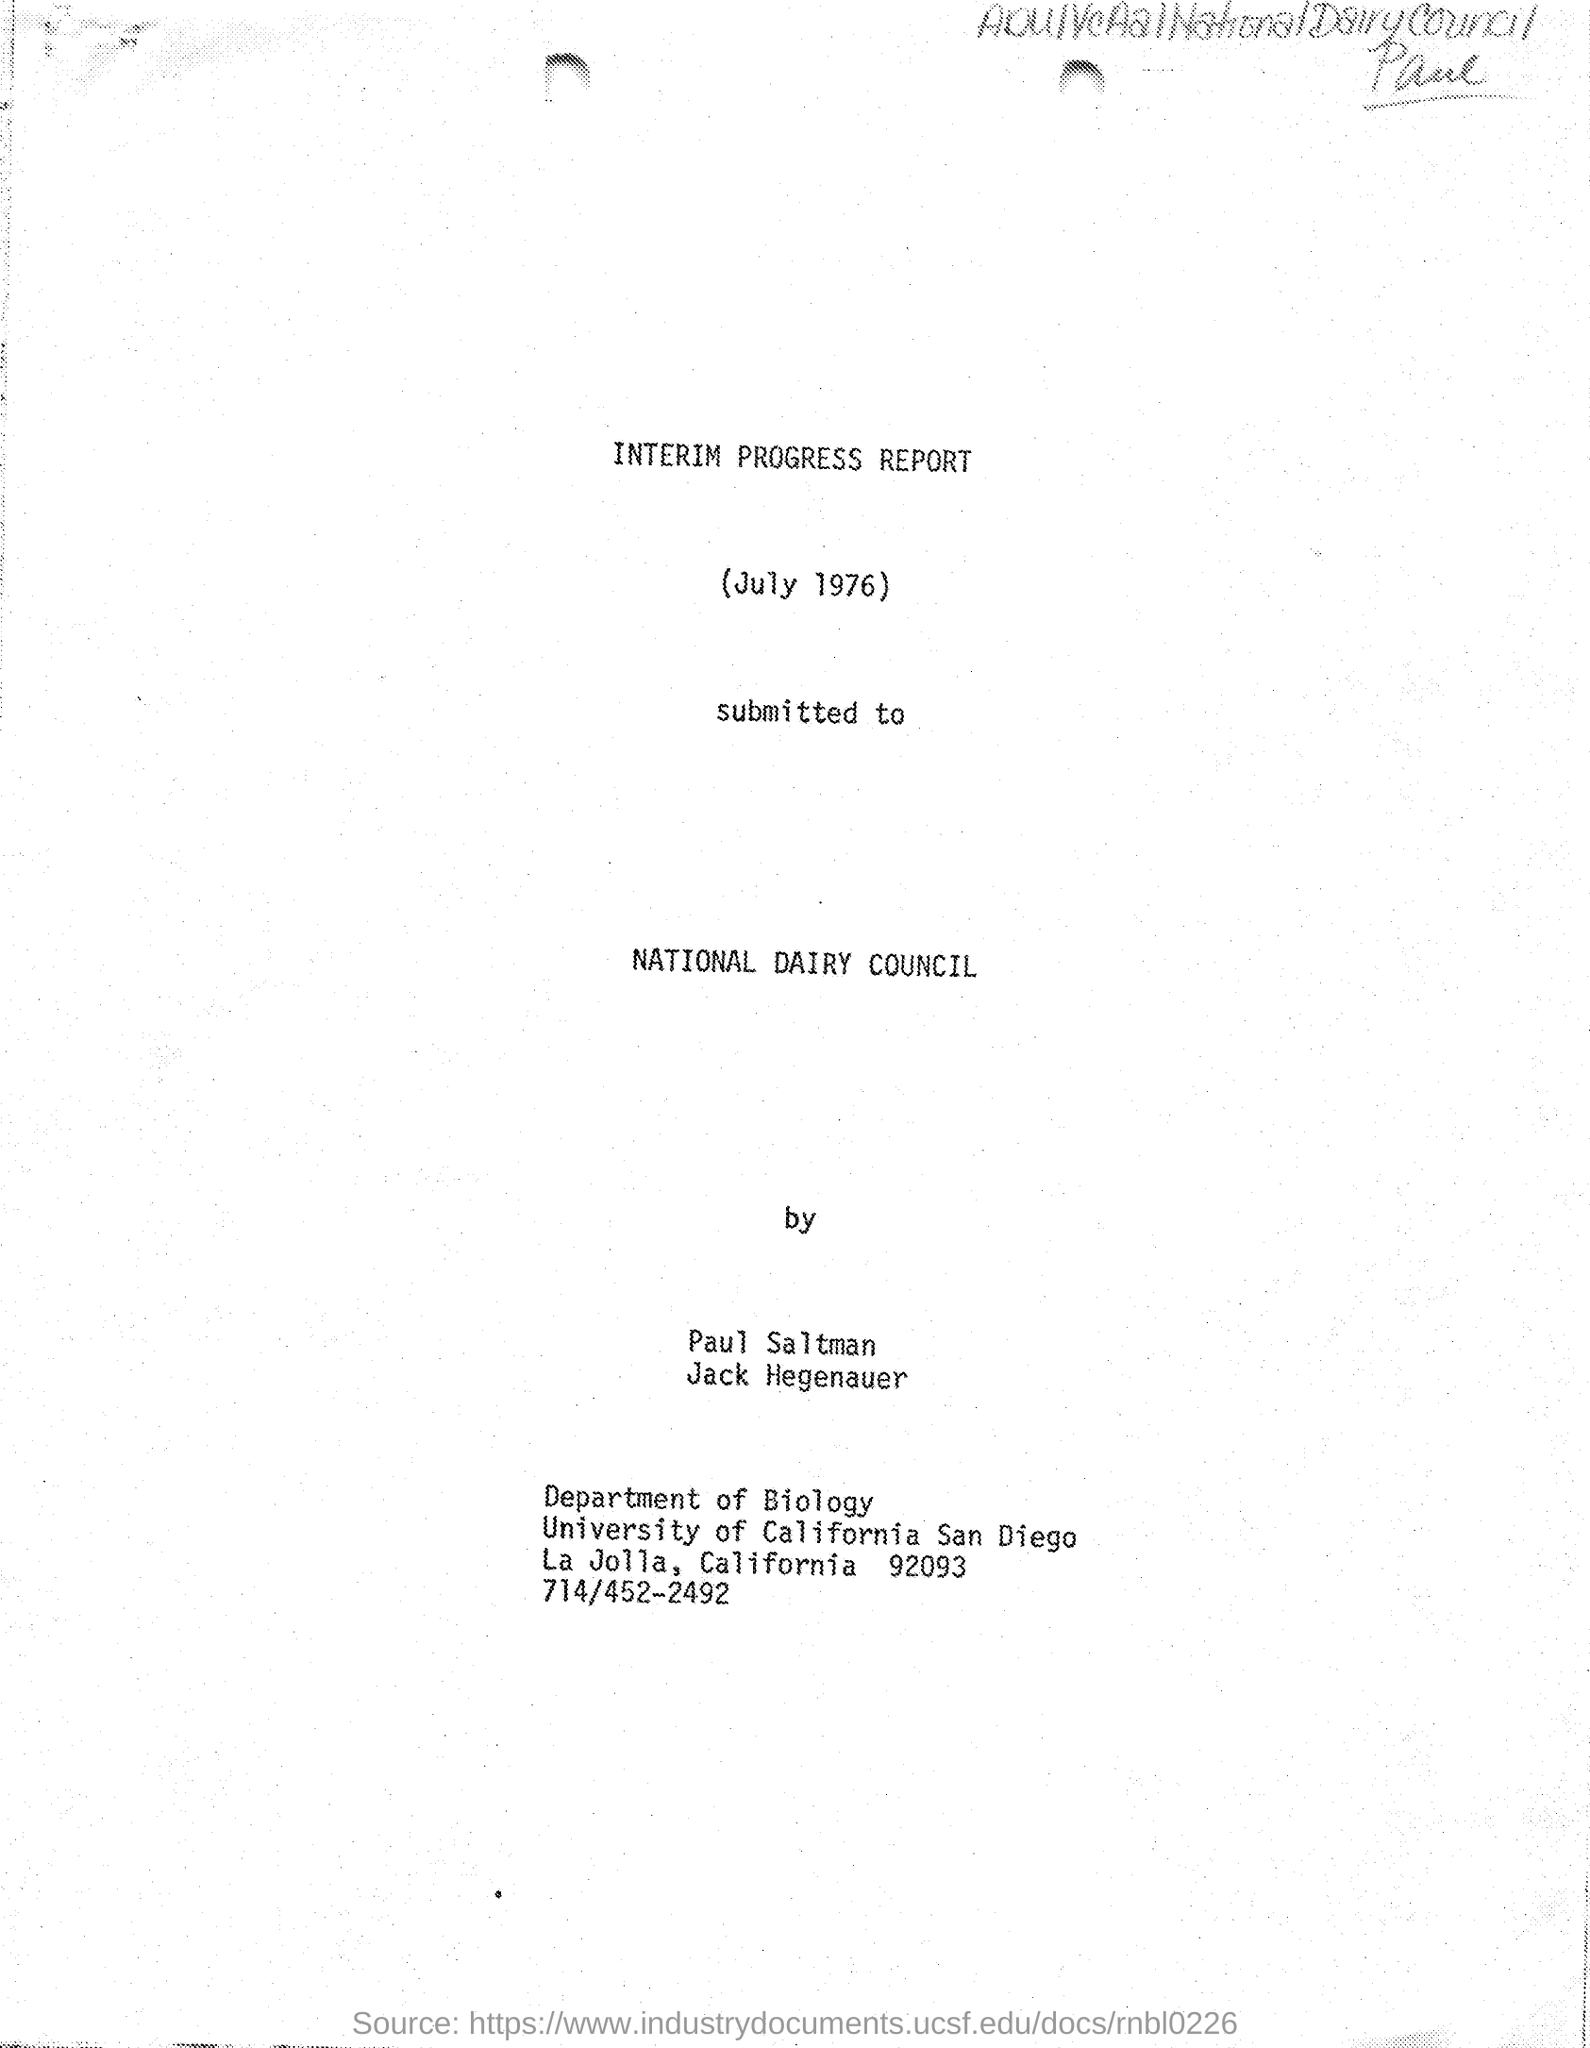What is the name of the report ?
Provide a succinct answer. INTERIM PROGRESS REPORT. What is the date mentioned in the given letter ?
Offer a terse response. July 1976. To whom the letter was submitted ?
Keep it short and to the point. NATIONAL DAIRY COUNCIL. What is the name of the department mentioned in the given letter ?
Offer a terse response. Department of biology. What is the phone number mentioned in the given letter ?
Your response must be concise. 714/452-2492. 